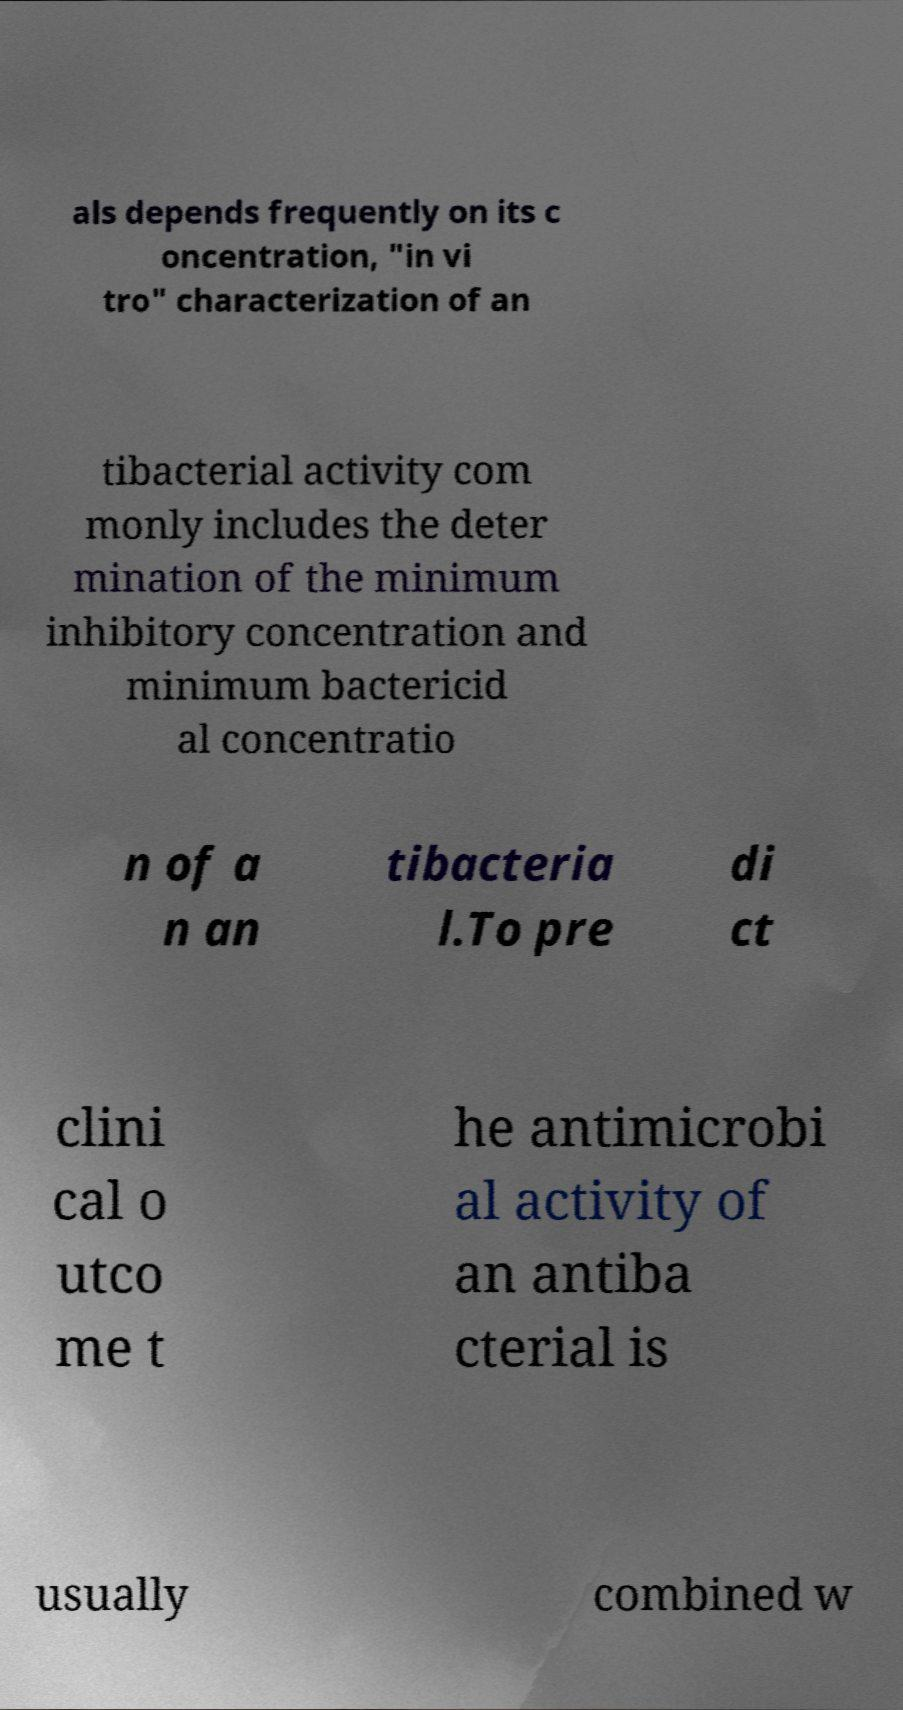Please identify and transcribe the text found in this image. als depends frequently on its c oncentration, "in vi tro" characterization of an tibacterial activity com monly includes the deter mination of the minimum inhibitory concentration and minimum bactericid al concentratio n of a n an tibacteria l.To pre di ct clini cal o utco me t he antimicrobi al activity of an antiba cterial is usually combined w 